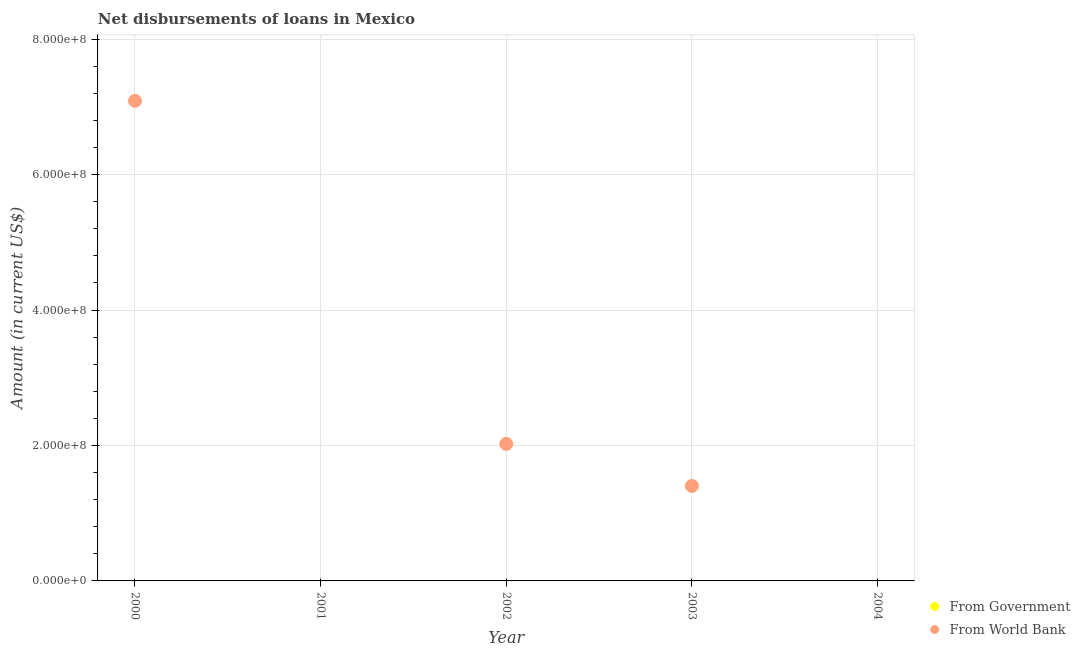How many different coloured dotlines are there?
Make the answer very short. 1. Is the number of dotlines equal to the number of legend labels?
Your answer should be compact. No. What is the net disbursements of loan from world bank in 2004?
Provide a succinct answer. 0. Across all years, what is the maximum net disbursements of loan from world bank?
Ensure brevity in your answer.  7.09e+08. Across all years, what is the minimum net disbursements of loan from world bank?
Offer a terse response. 0. In which year was the net disbursements of loan from world bank maximum?
Make the answer very short. 2000. What is the difference between the net disbursements of loan from world bank in 2000 and that in 2002?
Give a very brief answer. 5.07e+08. What is the average net disbursements of loan from government per year?
Your response must be concise. 0. In how many years, is the net disbursements of loan from world bank greater than 520000000 US$?
Your answer should be compact. 1. What is the difference between the highest and the second highest net disbursements of loan from world bank?
Ensure brevity in your answer.  5.07e+08. What is the difference between the highest and the lowest net disbursements of loan from world bank?
Offer a terse response. 7.09e+08. In how many years, is the net disbursements of loan from government greater than the average net disbursements of loan from government taken over all years?
Offer a very short reply. 0. Is the sum of the net disbursements of loan from world bank in 2000 and 2002 greater than the maximum net disbursements of loan from government across all years?
Offer a very short reply. Yes. Does the net disbursements of loan from government monotonically increase over the years?
Provide a succinct answer. No. Is the net disbursements of loan from government strictly less than the net disbursements of loan from world bank over the years?
Your answer should be compact. No. How many dotlines are there?
Your answer should be very brief. 1. Are the values on the major ticks of Y-axis written in scientific E-notation?
Provide a succinct answer. Yes. Does the graph contain any zero values?
Offer a very short reply. Yes. Does the graph contain grids?
Provide a short and direct response. Yes. Where does the legend appear in the graph?
Give a very brief answer. Bottom right. How many legend labels are there?
Ensure brevity in your answer.  2. What is the title of the graph?
Your answer should be very brief. Net disbursements of loans in Mexico. What is the Amount (in current US$) in From World Bank in 2000?
Ensure brevity in your answer.  7.09e+08. What is the Amount (in current US$) in From Government in 2001?
Offer a very short reply. 0. What is the Amount (in current US$) of From Government in 2002?
Offer a terse response. 0. What is the Amount (in current US$) of From World Bank in 2002?
Offer a very short reply. 2.02e+08. What is the Amount (in current US$) in From Government in 2003?
Provide a succinct answer. 0. What is the Amount (in current US$) of From World Bank in 2003?
Provide a short and direct response. 1.40e+08. What is the Amount (in current US$) in From World Bank in 2004?
Your answer should be compact. 0. Across all years, what is the maximum Amount (in current US$) of From World Bank?
Provide a short and direct response. 7.09e+08. What is the total Amount (in current US$) of From World Bank in the graph?
Offer a terse response. 1.05e+09. What is the difference between the Amount (in current US$) in From World Bank in 2000 and that in 2002?
Offer a terse response. 5.07e+08. What is the difference between the Amount (in current US$) in From World Bank in 2000 and that in 2003?
Your answer should be very brief. 5.69e+08. What is the difference between the Amount (in current US$) in From World Bank in 2002 and that in 2003?
Your answer should be very brief. 6.21e+07. What is the average Amount (in current US$) in From Government per year?
Ensure brevity in your answer.  0. What is the average Amount (in current US$) in From World Bank per year?
Offer a terse response. 2.10e+08. What is the ratio of the Amount (in current US$) of From World Bank in 2000 to that in 2002?
Your answer should be very brief. 3.5. What is the ratio of the Amount (in current US$) in From World Bank in 2000 to that in 2003?
Ensure brevity in your answer.  5.05. What is the ratio of the Amount (in current US$) of From World Bank in 2002 to that in 2003?
Ensure brevity in your answer.  1.44. What is the difference between the highest and the second highest Amount (in current US$) in From World Bank?
Your response must be concise. 5.07e+08. What is the difference between the highest and the lowest Amount (in current US$) of From World Bank?
Your answer should be compact. 7.09e+08. 